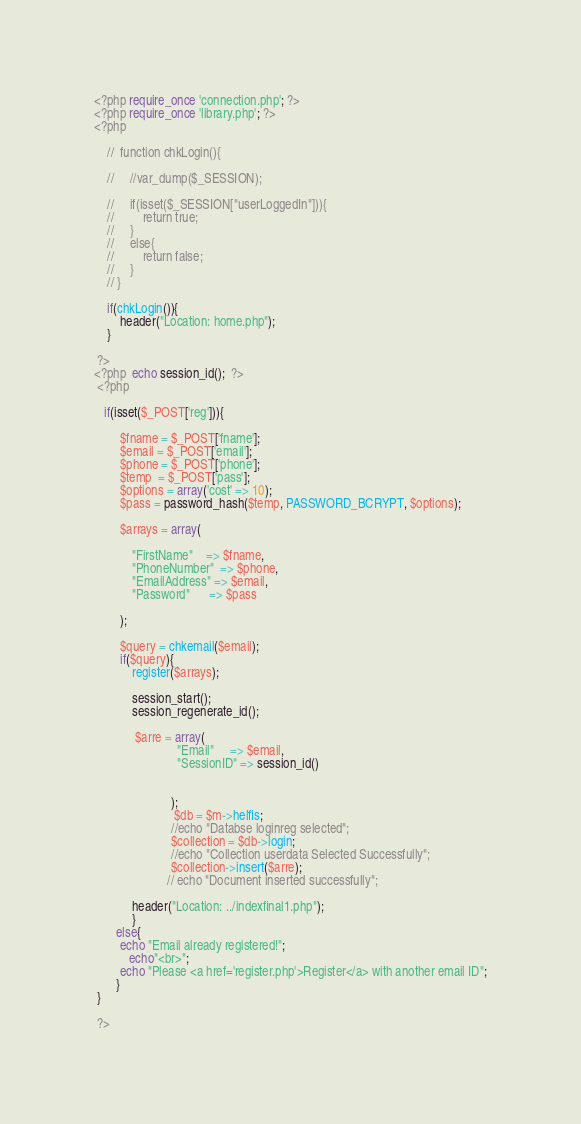Convert code to text. <code><loc_0><loc_0><loc_500><loc_500><_PHP_><?php require_once 'connection.php'; ?>
<?php require_once 'library.php'; ?>
<?php
     
    //  function chkLogin(){
        
    //     //var_dump($_SESSION);
        
    //     if(isset($_SESSION["userLoggedIn"])){
    //         return true;
    //     }
    //     else{
    //         return false;
    //     }
    // }
    
    if(chkLogin()){
        header("Location: home.php");
    }

 ?>
<?php  echo session_id();  ?>
 <?php
   
   if(isset($_POST['reg'])){
       
        $fname = $_POST['fname'];
        $email = $_POST['email'];
        $phone = $_POST['phone'];
        $temp  = $_POST['pass'];
        $options = array('cost' => 10);
        $pass = password_hash($temp, PASSWORD_BCRYPT, $options);
    
        $arrays = array(
            
            "FirstName"    => $fname,
            "PhoneNumber"  => $phone,
            "EmailAddress" => $email,
            "Password"      => $pass
        
        );
      
        $query = chkemail($email);
        if($query){
            register($arrays);

            session_start();
            session_regenerate_id();

             $arre = array(
                          "Email"     => $email,
                          "SessionID" => session_id()


                        );                     
                         $db = $m->helfis;
                        //echo "Databse loginreg selected";
                        $collection = $db->login; 
                        //echo "Collection userdata Selected Successfully";
                        $collection->insert($arre);
                       // echo "Document inserted successfully";

            header("Location: ../indexfinal1.php");
            }
       else{
        echo "Email already registered!";
           echo"<br>";
        echo "Please <a href='register.php'>Register</a> with another email ID";
       }
 }
       
 ?></code> 